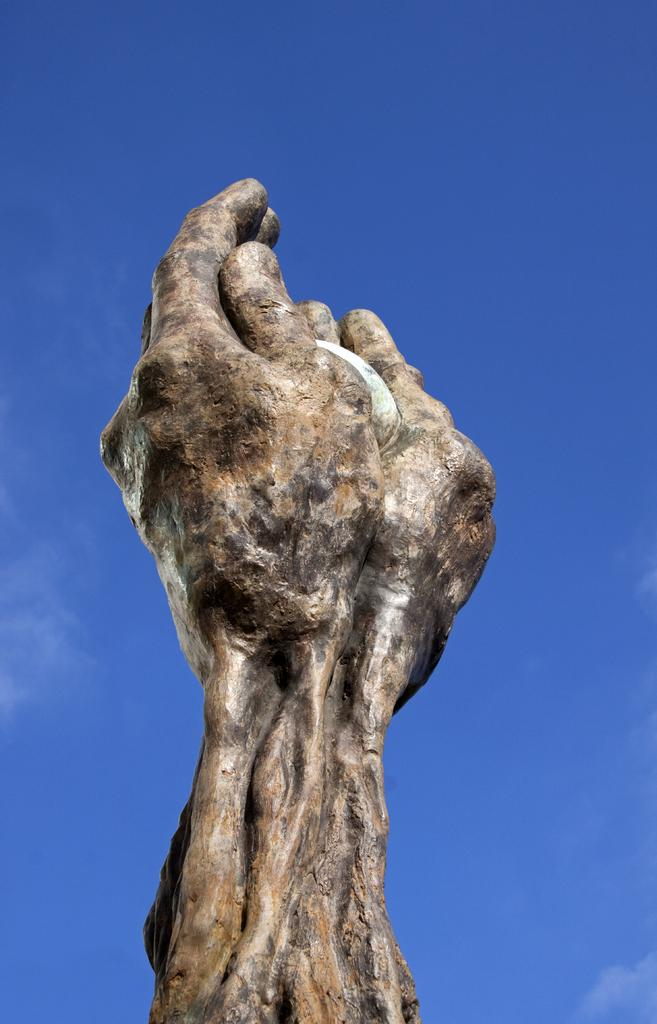What is the main subject of the image? There is a statue in the image. What material is the statue made of? The statue is carved on a stone. What can be seen in the background of the image? The background of the image includes the blue sky. How many leaves are on the statue in the image? There are no leaves present on the statue in the image, as it is carved on a stone. 